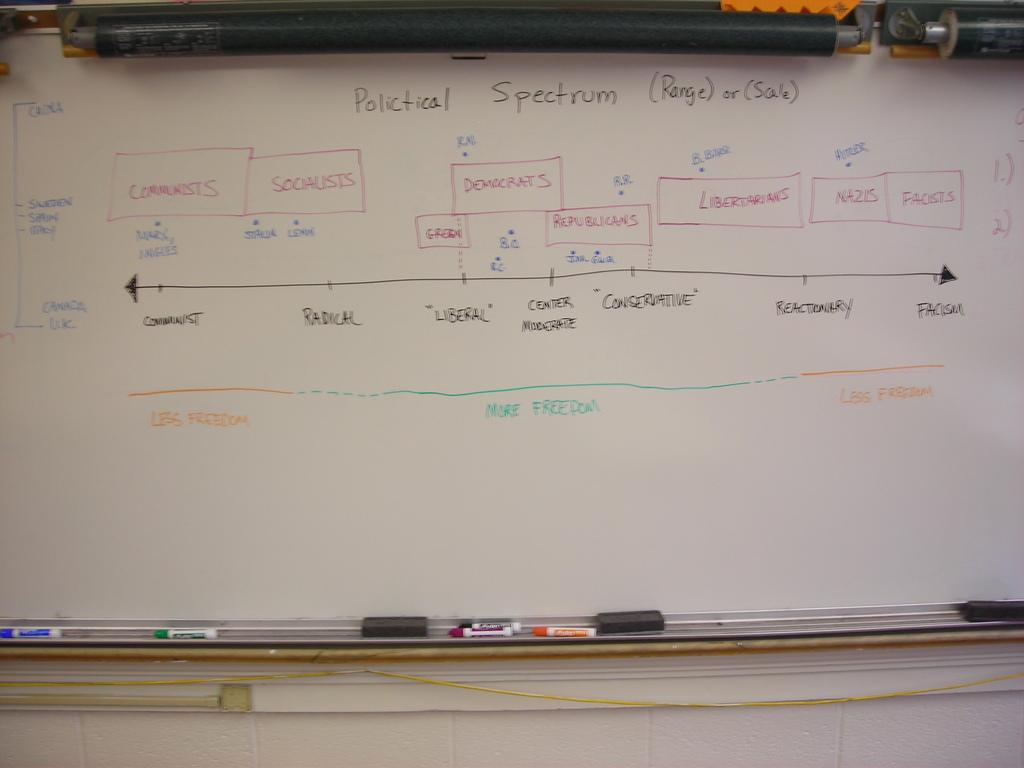<image>
Summarize the visual content of the image. a spectrum word at the top of a white board 